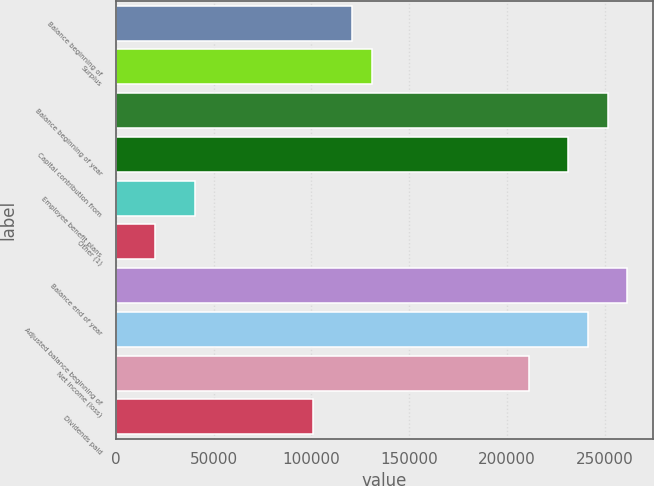Convert chart to OTSL. <chart><loc_0><loc_0><loc_500><loc_500><bar_chart><fcel>Balance beginning of<fcel>Surplus<fcel>Balance beginning of year<fcel>Capital contribution from<fcel>Employee benefit plans<fcel>Other (1)<fcel>Balance end of year<fcel>Adjusted balance beginning of<fcel>Net income (loss)<fcel>Dividends paid<nl><fcel>120685<fcel>130741<fcel>251418<fcel>231305<fcel>40233.6<fcel>20120.8<fcel>261474<fcel>241362<fcel>211192<fcel>100572<nl></chart> 